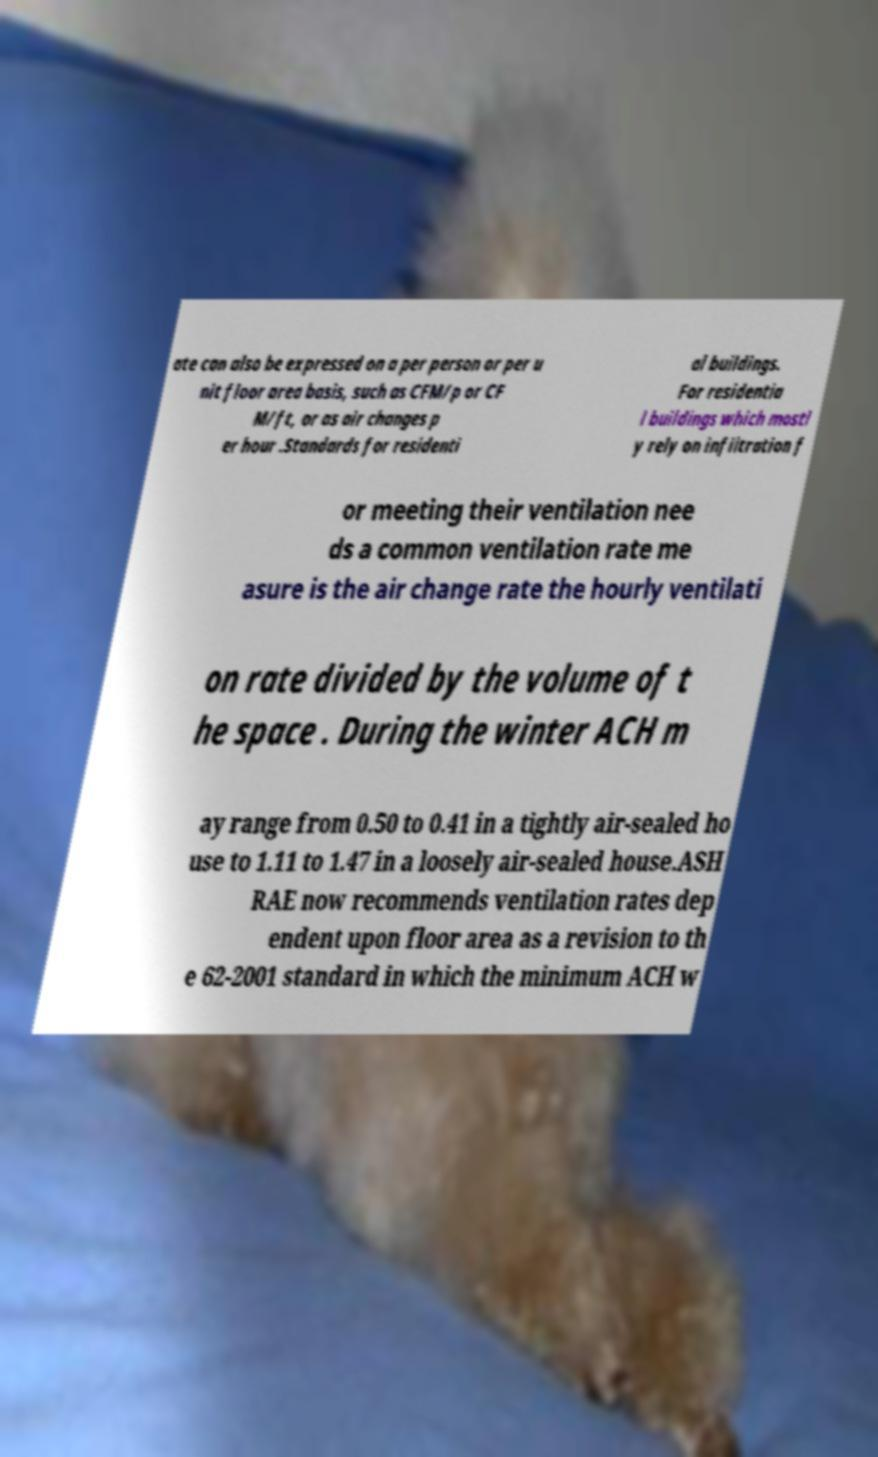Could you extract and type out the text from this image? ate can also be expressed on a per person or per u nit floor area basis, such as CFM/p or CF M/ft, or as air changes p er hour .Standards for residenti al buildings. For residentia l buildings which mostl y rely on infiltration f or meeting their ventilation nee ds a common ventilation rate me asure is the air change rate the hourly ventilati on rate divided by the volume of t he space . During the winter ACH m ay range from 0.50 to 0.41 in a tightly air-sealed ho use to 1.11 to 1.47 in a loosely air-sealed house.ASH RAE now recommends ventilation rates dep endent upon floor area as a revision to th e 62-2001 standard in which the minimum ACH w 